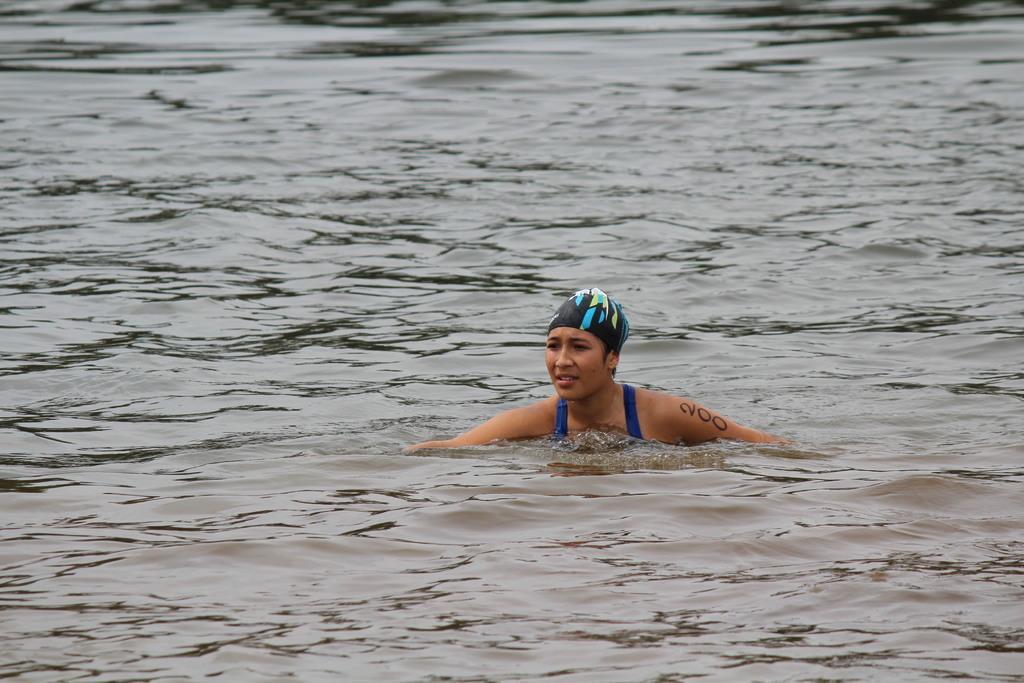Can you describe this image briefly? In this image there is a girl swimming in the water. 